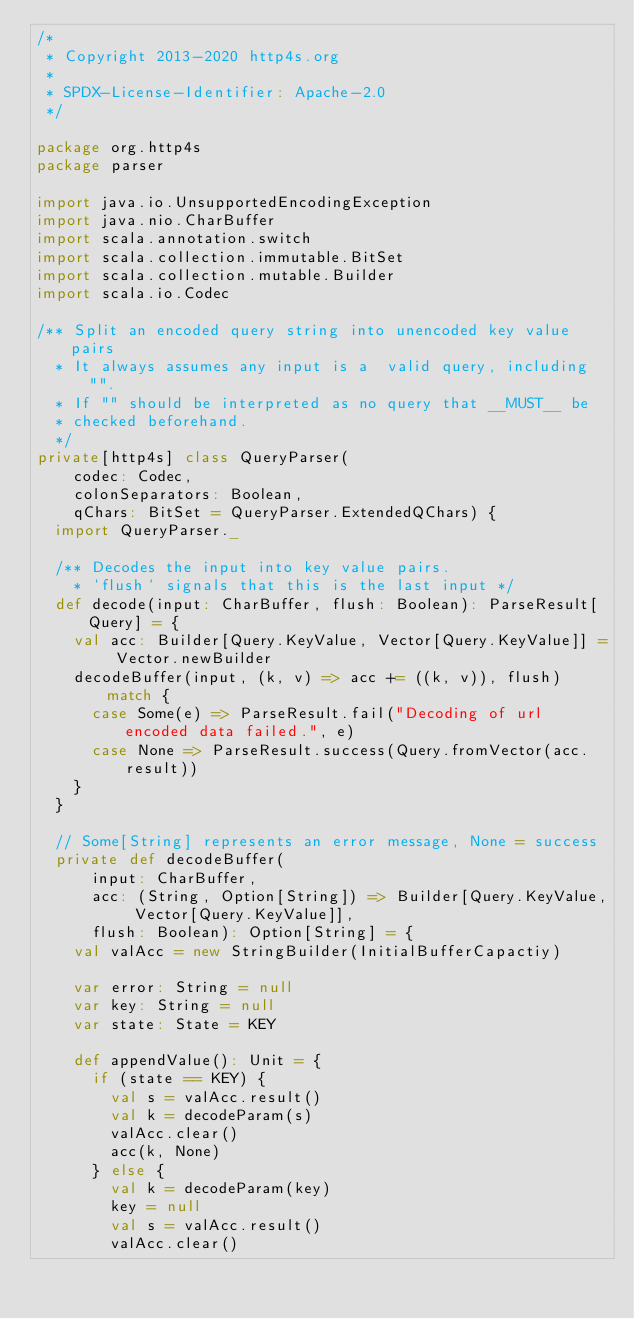Convert code to text. <code><loc_0><loc_0><loc_500><loc_500><_Scala_>/*
 * Copyright 2013-2020 http4s.org
 *
 * SPDX-License-Identifier: Apache-2.0
 */

package org.http4s
package parser

import java.io.UnsupportedEncodingException
import java.nio.CharBuffer
import scala.annotation.switch
import scala.collection.immutable.BitSet
import scala.collection.mutable.Builder
import scala.io.Codec

/** Split an encoded query string into unencoded key value pairs
  * It always assumes any input is a  valid query, including "".
  * If "" should be interpreted as no query that __MUST__ be
  * checked beforehand.
  */
private[http4s] class QueryParser(
    codec: Codec,
    colonSeparators: Boolean,
    qChars: BitSet = QueryParser.ExtendedQChars) {
  import QueryParser._

  /** Decodes the input into key value pairs.
    * `flush` signals that this is the last input */
  def decode(input: CharBuffer, flush: Boolean): ParseResult[Query] = {
    val acc: Builder[Query.KeyValue, Vector[Query.KeyValue]] = Vector.newBuilder
    decodeBuffer(input, (k, v) => acc += ((k, v)), flush) match {
      case Some(e) => ParseResult.fail("Decoding of url encoded data failed.", e)
      case None => ParseResult.success(Query.fromVector(acc.result))
    }
  }

  // Some[String] represents an error message, None = success
  private def decodeBuffer(
      input: CharBuffer,
      acc: (String, Option[String]) => Builder[Query.KeyValue, Vector[Query.KeyValue]],
      flush: Boolean): Option[String] = {
    val valAcc = new StringBuilder(InitialBufferCapactiy)

    var error: String = null
    var key: String = null
    var state: State = KEY

    def appendValue(): Unit = {
      if (state == KEY) {
        val s = valAcc.result()
        val k = decodeParam(s)
        valAcc.clear()
        acc(k, None)
      } else {
        val k = decodeParam(key)
        key = null
        val s = valAcc.result()
        valAcc.clear()</code> 